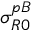Convert formula to latex. <formula><loc_0><loc_0><loc_500><loc_500>\sigma _ { R 0 } ^ { p B }</formula> 